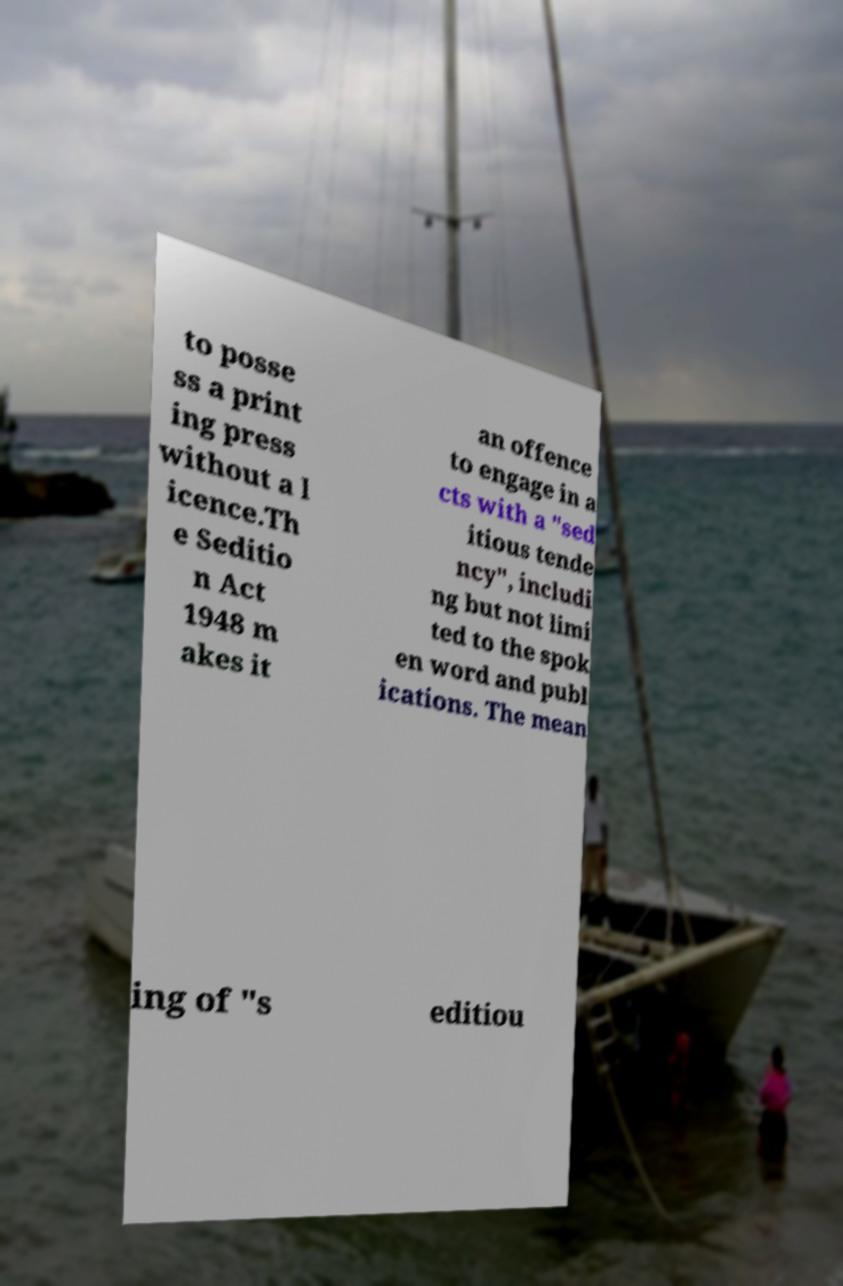Could you assist in decoding the text presented in this image and type it out clearly? to posse ss a print ing press without a l icence.Th e Seditio n Act 1948 m akes it an offence to engage in a cts with a "sed itious tende ncy", includi ng but not limi ted to the spok en word and publ ications. The mean ing of "s editiou 